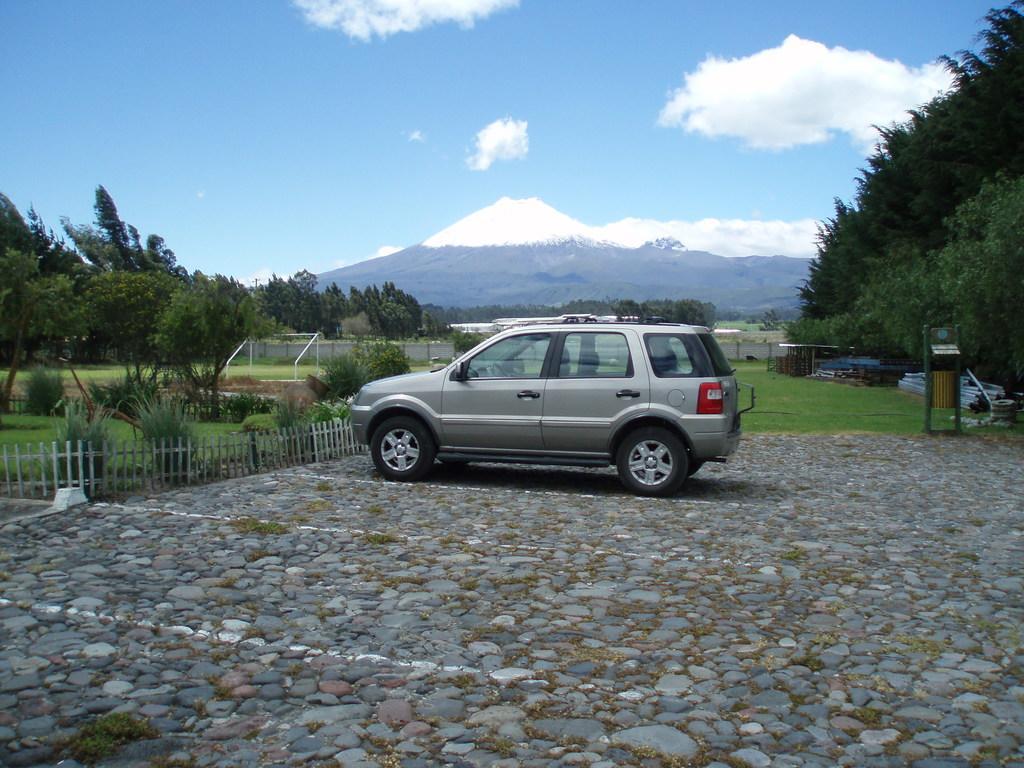In one or two sentences, can you explain what this image depicts? In this image there is the sky towards the top of the image, there are clouds in the sky, there are mountains, there are trees towards the right of the image, there are trees towards the left of the image, there is grass, there is a fence, there are poles, there is a dustbin towards the right of the image, there is a wooden fence towards the left of the image, there is a car, there are stones on the ground. 